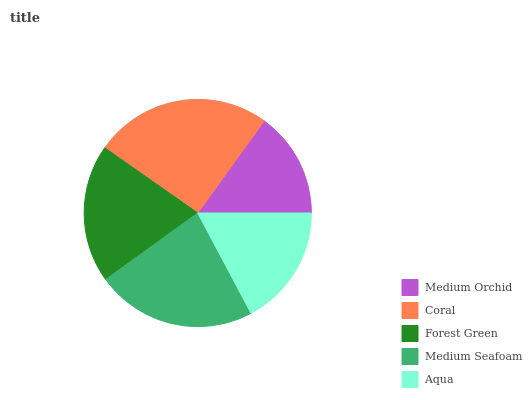Is Medium Orchid the minimum?
Answer yes or no. Yes. Is Coral the maximum?
Answer yes or no. Yes. Is Forest Green the minimum?
Answer yes or no. No. Is Forest Green the maximum?
Answer yes or no. No. Is Coral greater than Forest Green?
Answer yes or no. Yes. Is Forest Green less than Coral?
Answer yes or no. Yes. Is Forest Green greater than Coral?
Answer yes or no. No. Is Coral less than Forest Green?
Answer yes or no. No. Is Forest Green the high median?
Answer yes or no. Yes. Is Forest Green the low median?
Answer yes or no. Yes. Is Medium Orchid the high median?
Answer yes or no. No. Is Medium Seafoam the low median?
Answer yes or no. No. 